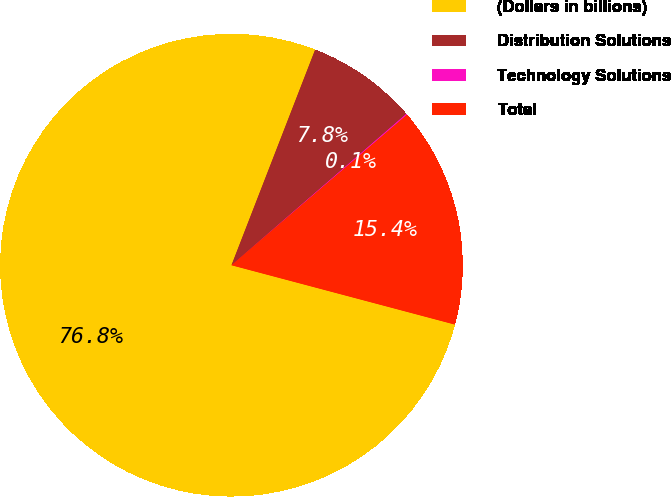Convert chart to OTSL. <chart><loc_0><loc_0><loc_500><loc_500><pie_chart><fcel>(Dollars in billions)<fcel>Distribution Solutions<fcel>Technology Solutions<fcel>Total<nl><fcel>76.76%<fcel>7.75%<fcel>0.08%<fcel>15.41%<nl></chart> 